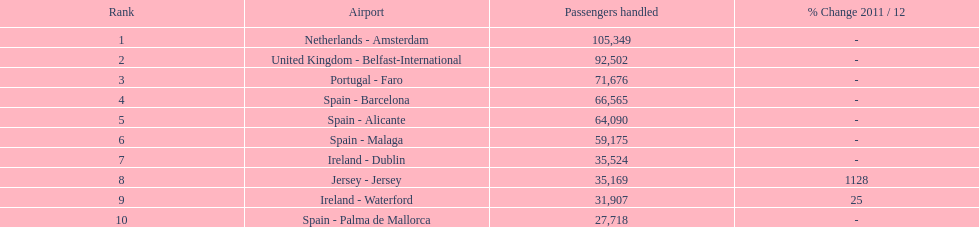What's the count of passengers en route to or coming back from spain? 217,548. 